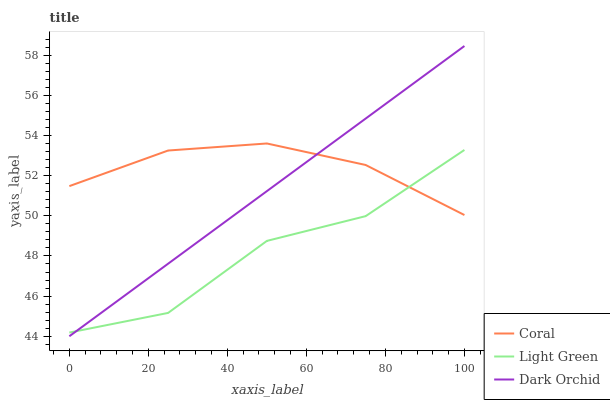Does Light Green have the minimum area under the curve?
Answer yes or no. Yes. Does Coral have the maximum area under the curve?
Answer yes or no. Yes. Does Dark Orchid have the minimum area under the curve?
Answer yes or no. No. Does Dark Orchid have the maximum area under the curve?
Answer yes or no. No. Is Dark Orchid the smoothest?
Answer yes or no. Yes. Is Light Green the roughest?
Answer yes or no. Yes. Is Light Green the smoothest?
Answer yes or no. No. Is Dark Orchid the roughest?
Answer yes or no. No. Does Dark Orchid have the lowest value?
Answer yes or no. Yes. Does Light Green have the lowest value?
Answer yes or no. No. Does Dark Orchid have the highest value?
Answer yes or no. Yes. Does Light Green have the highest value?
Answer yes or no. No. Does Dark Orchid intersect Coral?
Answer yes or no. Yes. Is Dark Orchid less than Coral?
Answer yes or no. No. Is Dark Orchid greater than Coral?
Answer yes or no. No. 